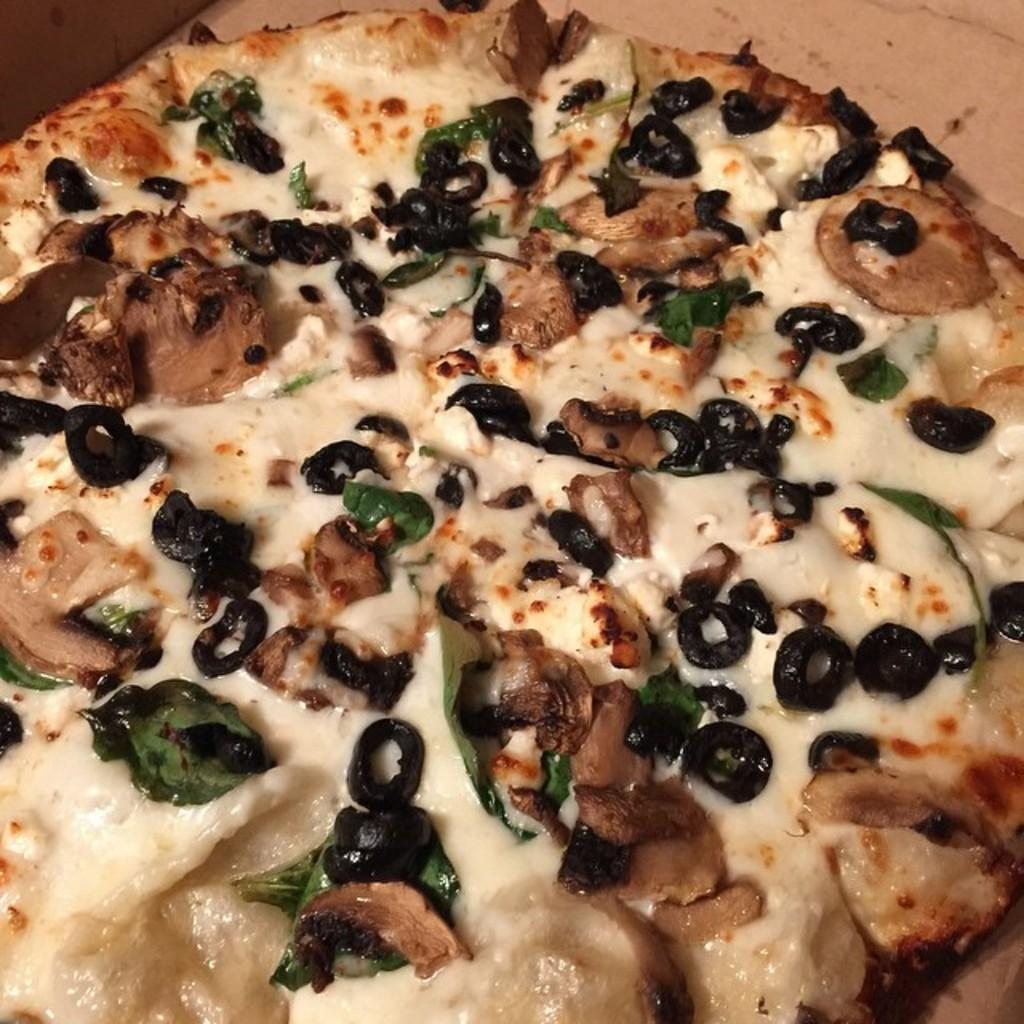What type of food is shown in the image? There is a pizza in the image. Can you describe any specific toppings on the pizza? Yes, there are black color objects on the pizza. What type of fang can be seen on the coast in the image? There is no fang or coast present in the image; it only features a pizza with black color objects on it. 